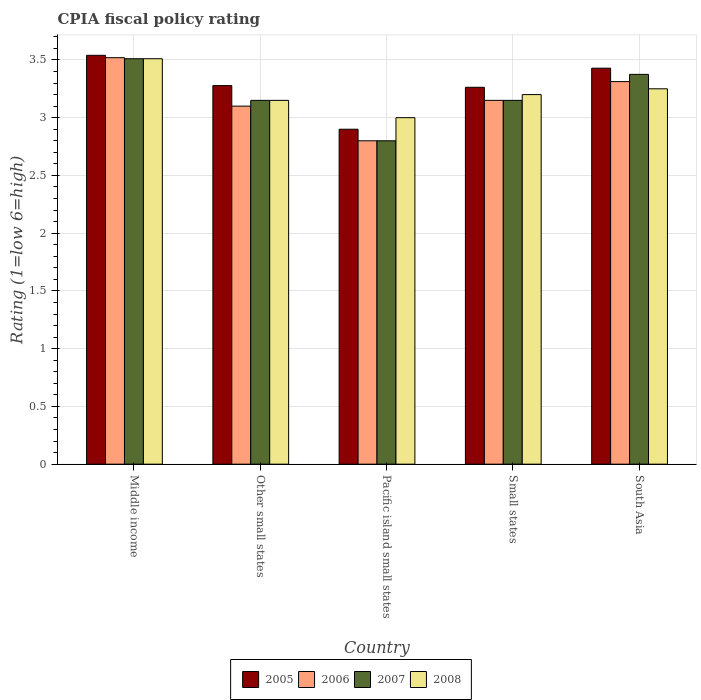How many different coloured bars are there?
Keep it short and to the point. 4. Are the number of bars per tick equal to the number of legend labels?
Keep it short and to the point. Yes. How many bars are there on the 4th tick from the right?
Give a very brief answer. 4. What is the label of the 4th group of bars from the left?
Your response must be concise. Small states. In how many cases, is the number of bars for a given country not equal to the number of legend labels?
Your answer should be compact. 0. What is the CPIA rating in 2005 in South Asia?
Keep it short and to the point. 3.43. Across all countries, what is the maximum CPIA rating in 2005?
Keep it short and to the point. 3.54. In which country was the CPIA rating in 2006 maximum?
Give a very brief answer. Middle income. In which country was the CPIA rating in 2007 minimum?
Offer a very short reply. Pacific island small states. What is the total CPIA rating in 2007 in the graph?
Your answer should be compact. 15.99. What is the difference between the CPIA rating in 2006 in Middle income and that in Other small states?
Your answer should be compact. 0.42. What is the difference between the CPIA rating in 2007 in South Asia and the CPIA rating in 2005 in Small states?
Make the answer very short. 0.11. What is the average CPIA rating in 2006 per country?
Give a very brief answer. 3.18. What is the difference between the CPIA rating of/in 2007 and CPIA rating of/in 2008 in Pacific island small states?
Keep it short and to the point. -0.2. In how many countries, is the CPIA rating in 2008 greater than 1.3?
Provide a short and direct response. 5. What is the ratio of the CPIA rating in 2008 in Other small states to that in Pacific island small states?
Give a very brief answer. 1.05. Is the CPIA rating in 2006 in Other small states less than that in Small states?
Ensure brevity in your answer.  Yes. What is the difference between the highest and the second highest CPIA rating in 2005?
Provide a succinct answer. -0.11. What is the difference between the highest and the lowest CPIA rating in 2007?
Your answer should be very brief. 0.71. Is it the case that in every country, the sum of the CPIA rating in 2006 and CPIA rating in 2005 is greater than the sum of CPIA rating in 2007 and CPIA rating in 2008?
Keep it short and to the point. No. What does the 3rd bar from the left in Pacific island small states represents?
Keep it short and to the point. 2007. What does the 3rd bar from the right in South Asia represents?
Provide a succinct answer. 2006. Is it the case that in every country, the sum of the CPIA rating in 2006 and CPIA rating in 2008 is greater than the CPIA rating in 2005?
Keep it short and to the point. Yes. Are all the bars in the graph horizontal?
Your answer should be very brief. No. How many countries are there in the graph?
Keep it short and to the point. 5. Does the graph contain any zero values?
Make the answer very short. No. Does the graph contain grids?
Provide a succinct answer. Yes. How many legend labels are there?
Offer a very short reply. 4. How are the legend labels stacked?
Provide a short and direct response. Horizontal. What is the title of the graph?
Provide a succinct answer. CPIA fiscal policy rating. What is the label or title of the Y-axis?
Offer a terse response. Rating (1=low 6=high). What is the Rating (1=low 6=high) of 2005 in Middle income?
Offer a very short reply. 3.54. What is the Rating (1=low 6=high) in 2006 in Middle income?
Keep it short and to the point. 3.52. What is the Rating (1=low 6=high) in 2007 in Middle income?
Give a very brief answer. 3.51. What is the Rating (1=low 6=high) in 2008 in Middle income?
Your answer should be compact. 3.51. What is the Rating (1=low 6=high) in 2005 in Other small states?
Your answer should be very brief. 3.28. What is the Rating (1=low 6=high) in 2006 in Other small states?
Offer a terse response. 3.1. What is the Rating (1=low 6=high) in 2007 in Other small states?
Provide a short and direct response. 3.15. What is the Rating (1=low 6=high) in 2008 in Other small states?
Your response must be concise. 3.15. What is the Rating (1=low 6=high) in 2006 in Pacific island small states?
Give a very brief answer. 2.8. What is the Rating (1=low 6=high) of 2008 in Pacific island small states?
Provide a short and direct response. 3. What is the Rating (1=low 6=high) of 2005 in Small states?
Give a very brief answer. 3.26. What is the Rating (1=low 6=high) of 2006 in Small states?
Your answer should be very brief. 3.15. What is the Rating (1=low 6=high) of 2007 in Small states?
Offer a very short reply. 3.15. What is the Rating (1=low 6=high) of 2008 in Small states?
Offer a very short reply. 3.2. What is the Rating (1=low 6=high) in 2005 in South Asia?
Provide a short and direct response. 3.43. What is the Rating (1=low 6=high) of 2006 in South Asia?
Provide a succinct answer. 3.31. What is the Rating (1=low 6=high) in 2007 in South Asia?
Offer a terse response. 3.38. Across all countries, what is the maximum Rating (1=low 6=high) of 2005?
Your answer should be very brief. 3.54. Across all countries, what is the maximum Rating (1=low 6=high) in 2006?
Provide a short and direct response. 3.52. Across all countries, what is the maximum Rating (1=low 6=high) in 2007?
Your answer should be very brief. 3.51. Across all countries, what is the maximum Rating (1=low 6=high) of 2008?
Your answer should be compact. 3.51. Across all countries, what is the minimum Rating (1=low 6=high) of 2006?
Your response must be concise. 2.8. Across all countries, what is the minimum Rating (1=low 6=high) in 2008?
Your answer should be compact. 3. What is the total Rating (1=low 6=high) in 2005 in the graph?
Your answer should be compact. 16.41. What is the total Rating (1=low 6=high) of 2006 in the graph?
Provide a short and direct response. 15.88. What is the total Rating (1=low 6=high) in 2007 in the graph?
Make the answer very short. 15.99. What is the total Rating (1=low 6=high) in 2008 in the graph?
Give a very brief answer. 16.11. What is the difference between the Rating (1=low 6=high) in 2005 in Middle income and that in Other small states?
Keep it short and to the point. 0.26. What is the difference between the Rating (1=low 6=high) in 2006 in Middle income and that in Other small states?
Offer a terse response. 0.42. What is the difference between the Rating (1=low 6=high) of 2007 in Middle income and that in Other small states?
Your answer should be compact. 0.36. What is the difference between the Rating (1=low 6=high) in 2008 in Middle income and that in Other small states?
Provide a short and direct response. 0.36. What is the difference between the Rating (1=low 6=high) in 2005 in Middle income and that in Pacific island small states?
Provide a succinct answer. 0.64. What is the difference between the Rating (1=low 6=high) in 2006 in Middle income and that in Pacific island small states?
Your answer should be compact. 0.72. What is the difference between the Rating (1=low 6=high) in 2007 in Middle income and that in Pacific island small states?
Give a very brief answer. 0.71. What is the difference between the Rating (1=low 6=high) in 2008 in Middle income and that in Pacific island small states?
Give a very brief answer. 0.51. What is the difference between the Rating (1=low 6=high) in 2005 in Middle income and that in Small states?
Offer a very short reply. 0.28. What is the difference between the Rating (1=low 6=high) of 2006 in Middle income and that in Small states?
Your response must be concise. 0.37. What is the difference between the Rating (1=low 6=high) in 2007 in Middle income and that in Small states?
Provide a short and direct response. 0.36. What is the difference between the Rating (1=low 6=high) in 2008 in Middle income and that in Small states?
Keep it short and to the point. 0.31. What is the difference between the Rating (1=low 6=high) of 2005 in Middle income and that in South Asia?
Provide a short and direct response. 0.11. What is the difference between the Rating (1=low 6=high) in 2006 in Middle income and that in South Asia?
Keep it short and to the point. 0.21. What is the difference between the Rating (1=low 6=high) in 2007 in Middle income and that in South Asia?
Your answer should be very brief. 0.14. What is the difference between the Rating (1=low 6=high) of 2008 in Middle income and that in South Asia?
Ensure brevity in your answer.  0.26. What is the difference between the Rating (1=low 6=high) of 2005 in Other small states and that in Pacific island small states?
Your answer should be very brief. 0.38. What is the difference between the Rating (1=low 6=high) in 2007 in Other small states and that in Pacific island small states?
Make the answer very short. 0.35. What is the difference between the Rating (1=low 6=high) in 2008 in Other small states and that in Pacific island small states?
Make the answer very short. 0.15. What is the difference between the Rating (1=low 6=high) of 2005 in Other small states and that in Small states?
Offer a terse response. 0.01. What is the difference between the Rating (1=low 6=high) in 2005 in Other small states and that in South Asia?
Keep it short and to the point. -0.15. What is the difference between the Rating (1=low 6=high) of 2006 in Other small states and that in South Asia?
Ensure brevity in your answer.  -0.21. What is the difference between the Rating (1=low 6=high) in 2007 in Other small states and that in South Asia?
Your answer should be compact. -0.23. What is the difference between the Rating (1=low 6=high) of 2008 in Other small states and that in South Asia?
Your response must be concise. -0.1. What is the difference between the Rating (1=low 6=high) of 2005 in Pacific island small states and that in Small states?
Ensure brevity in your answer.  -0.36. What is the difference between the Rating (1=low 6=high) of 2006 in Pacific island small states and that in Small states?
Your response must be concise. -0.35. What is the difference between the Rating (1=low 6=high) of 2007 in Pacific island small states and that in Small states?
Keep it short and to the point. -0.35. What is the difference between the Rating (1=low 6=high) of 2005 in Pacific island small states and that in South Asia?
Ensure brevity in your answer.  -0.53. What is the difference between the Rating (1=low 6=high) in 2006 in Pacific island small states and that in South Asia?
Your response must be concise. -0.51. What is the difference between the Rating (1=low 6=high) of 2007 in Pacific island small states and that in South Asia?
Offer a very short reply. -0.57. What is the difference between the Rating (1=low 6=high) of 2005 in Small states and that in South Asia?
Provide a succinct answer. -0.17. What is the difference between the Rating (1=low 6=high) in 2006 in Small states and that in South Asia?
Your answer should be very brief. -0.16. What is the difference between the Rating (1=low 6=high) in 2007 in Small states and that in South Asia?
Your answer should be very brief. -0.23. What is the difference between the Rating (1=low 6=high) of 2005 in Middle income and the Rating (1=low 6=high) of 2006 in Other small states?
Keep it short and to the point. 0.44. What is the difference between the Rating (1=low 6=high) in 2005 in Middle income and the Rating (1=low 6=high) in 2007 in Other small states?
Provide a succinct answer. 0.39. What is the difference between the Rating (1=low 6=high) in 2005 in Middle income and the Rating (1=low 6=high) in 2008 in Other small states?
Make the answer very short. 0.39. What is the difference between the Rating (1=low 6=high) of 2006 in Middle income and the Rating (1=low 6=high) of 2007 in Other small states?
Provide a short and direct response. 0.37. What is the difference between the Rating (1=low 6=high) in 2006 in Middle income and the Rating (1=low 6=high) in 2008 in Other small states?
Ensure brevity in your answer.  0.37. What is the difference between the Rating (1=low 6=high) of 2007 in Middle income and the Rating (1=low 6=high) of 2008 in Other small states?
Provide a succinct answer. 0.36. What is the difference between the Rating (1=low 6=high) of 2005 in Middle income and the Rating (1=low 6=high) of 2006 in Pacific island small states?
Offer a terse response. 0.74. What is the difference between the Rating (1=low 6=high) of 2005 in Middle income and the Rating (1=low 6=high) of 2007 in Pacific island small states?
Ensure brevity in your answer.  0.74. What is the difference between the Rating (1=low 6=high) in 2005 in Middle income and the Rating (1=low 6=high) in 2008 in Pacific island small states?
Your response must be concise. 0.54. What is the difference between the Rating (1=low 6=high) of 2006 in Middle income and the Rating (1=low 6=high) of 2007 in Pacific island small states?
Give a very brief answer. 0.72. What is the difference between the Rating (1=low 6=high) of 2006 in Middle income and the Rating (1=low 6=high) of 2008 in Pacific island small states?
Make the answer very short. 0.52. What is the difference between the Rating (1=low 6=high) in 2007 in Middle income and the Rating (1=low 6=high) in 2008 in Pacific island small states?
Offer a terse response. 0.51. What is the difference between the Rating (1=low 6=high) in 2005 in Middle income and the Rating (1=low 6=high) in 2006 in Small states?
Provide a short and direct response. 0.39. What is the difference between the Rating (1=low 6=high) in 2005 in Middle income and the Rating (1=low 6=high) in 2007 in Small states?
Your response must be concise. 0.39. What is the difference between the Rating (1=low 6=high) in 2005 in Middle income and the Rating (1=low 6=high) in 2008 in Small states?
Ensure brevity in your answer.  0.34. What is the difference between the Rating (1=low 6=high) in 2006 in Middle income and the Rating (1=low 6=high) in 2007 in Small states?
Your answer should be compact. 0.37. What is the difference between the Rating (1=low 6=high) in 2006 in Middle income and the Rating (1=low 6=high) in 2008 in Small states?
Provide a short and direct response. 0.32. What is the difference between the Rating (1=low 6=high) in 2007 in Middle income and the Rating (1=low 6=high) in 2008 in Small states?
Make the answer very short. 0.31. What is the difference between the Rating (1=low 6=high) of 2005 in Middle income and the Rating (1=low 6=high) of 2006 in South Asia?
Offer a very short reply. 0.23. What is the difference between the Rating (1=low 6=high) in 2005 in Middle income and the Rating (1=low 6=high) in 2007 in South Asia?
Your answer should be very brief. 0.17. What is the difference between the Rating (1=low 6=high) of 2005 in Middle income and the Rating (1=low 6=high) of 2008 in South Asia?
Offer a terse response. 0.29. What is the difference between the Rating (1=low 6=high) of 2006 in Middle income and the Rating (1=low 6=high) of 2007 in South Asia?
Offer a very short reply. 0.14. What is the difference between the Rating (1=low 6=high) of 2006 in Middle income and the Rating (1=low 6=high) of 2008 in South Asia?
Offer a terse response. 0.27. What is the difference between the Rating (1=low 6=high) in 2007 in Middle income and the Rating (1=low 6=high) in 2008 in South Asia?
Make the answer very short. 0.26. What is the difference between the Rating (1=low 6=high) of 2005 in Other small states and the Rating (1=low 6=high) of 2006 in Pacific island small states?
Make the answer very short. 0.48. What is the difference between the Rating (1=low 6=high) in 2005 in Other small states and the Rating (1=low 6=high) in 2007 in Pacific island small states?
Keep it short and to the point. 0.48. What is the difference between the Rating (1=low 6=high) in 2005 in Other small states and the Rating (1=low 6=high) in 2008 in Pacific island small states?
Your response must be concise. 0.28. What is the difference between the Rating (1=low 6=high) of 2006 in Other small states and the Rating (1=low 6=high) of 2008 in Pacific island small states?
Make the answer very short. 0.1. What is the difference between the Rating (1=low 6=high) of 2005 in Other small states and the Rating (1=low 6=high) of 2006 in Small states?
Offer a terse response. 0.13. What is the difference between the Rating (1=low 6=high) of 2005 in Other small states and the Rating (1=low 6=high) of 2007 in Small states?
Ensure brevity in your answer.  0.13. What is the difference between the Rating (1=low 6=high) of 2005 in Other small states and the Rating (1=low 6=high) of 2008 in Small states?
Offer a terse response. 0.08. What is the difference between the Rating (1=low 6=high) in 2005 in Other small states and the Rating (1=low 6=high) in 2006 in South Asia?
Give a very brief answer. -0.03. What is the difference between the Rating (1=low 6=high) of 2005 in Other small states and the Rating (1=low 6=high) of 2007 in South Asia?
Provide a short and direct response. -0.1. What is the difference between the Rating (1=low 6=high) in 2005 in Other small states and the Rating (1=low 6=high) in 2008 in South Asia?
Offer a very short reply. 0.03. What is the difference between the Rating (1=low 6=high) of 2006 in Other small states and the Rating (1=low 6=high) of 2007 in South Asia?
Keep it short and to the point. -0.28. What is the difference between the Rating (1=low 6=high) in 2006 in Other small states and the Rating (1=low 6=high) in 2008 in South Asia?
Provide a short and direct response. -0.15. What is the difference between the Rating (1=low 6=high) in 2006 in Pacific island small states and the Rating (1=low 6=high) in 2007 in Small states?
Your answer should be compact. -0.35. What is the difference between the Rating (1=low 6=high) in 2007 in Pacific island small states and the Rating (1=low 6=high) in 2008 in Small states?
Provide a short and direct response. -0.4. What is the difference between the Rating (1=low 6=high) in 2005 in Pacific island small states and the Rating (1=low 6=high) in 2006 in South Asia?
Your answer should be compact. -0.41. What is the difference between the Rating (1=low 6=high) in 2005 in Pacific island small states and the Rating (1=low 6=high) in 2007 in South Asia?
Offer a very short reply. -0.47. What is the difference between the Rating (1=low 6=high) of 2005 in Pacific island small states and the Rating (1=low 6=high) of 2008 in South Asia?
Provide a succinct answer. -0.35. What is the difference between the Rating (1=low 6=high) in 2006 in Pacific island small states and the Rating (1=low 6=high) in 2007 in South Asia?
Offer a very short reply. -0.57. What is the difference between the Rating (1=low 6=high) of 2006 in Pacific island small states and the Rating (1=low 6=high) of 2008 in South Asia?
Ensure brevity in your answer.  -0.45. What is the difference between the Rating (1=low 6=high) in 2007 in Pacific island small states and the Rating (1=low 6=high) in 2008 in South Asia?
Provide a short and direct response. -0.45. What is the difference between the Rating (1=low 6=high) in 2005 in Small states and the Rating (1=low 6=high) in 2006 in South Asia?
Offer a very short reply. -0.05. What is the difference between the Rating (1=low 6=high) in 2005 in Small states and the Rating (1=low 6=high) in 2007 in South Asia?
Make the answer very short. -0.11. What is the difference between the Rating (1=low 6=high) in 2005 in Small states and the Rating (1=low 6=high) in 2008 in South Asia?
Provide a short and direct response. 0.01. What is the difference between the Rating (1=low 6=high) of 2006 in Small states and the Rating (1=low 6=high) of 2007 in South Asia?
Provide a short and direct response. -0.23. What is the difference between the Rating (1=low 6=high) of 2007 in Small states and the Rating (1=low 6=high) of 2008 in South Asia?
Make the answer very short. -0.1. What is the average Rating (1=low 6=high) of 2005 per country?
Provide a succinct answer. 3.28. What is the average Rating (1=low 6=high) of 2006 per country?
Provide a succinct answer. 3.18. What is the average Rating (1=low 6=high) of 2007 per country?
Your answer should be compact. 3.2. What is the average Rating (1=low 6=high) of 2008 per country?
Provide a short and direct response. 3.22. What is the difference between the Rating (1=low 6=high) in 2005 and Rating (1=low 6=high) in 2006 in Middle income?
Your answer should be compact. 0.02. What is the difference between the Rating (1=low 6=high) of 2005 and Rating (1=low 6=high) of 2007 in Middle income?
Your response must be concise. 0.03. What is the difference between the Rating (1=low 6=high) in 2005 and Rating (1=low 6=high) in 2008 in Middle income?
Keep it short and to the point. 0.03. What is the difference between the Rating (1=low 6=high) of 2006 and Rating (1=low 6=high) of 2007 in Middle income?
Offer a terse response. 0.01. What is the difference between the Rating (1=low 6=high) in 2006 and Rating (1=low 6=high) in 2008 in Middle income?
Keep it short and to the point. 0.01. What is the difference between the Rating (1=low 6=high) in 2007 and Rating (1=low 6=high) in 2008 in Middle income?
Provide a short and direct response. 0. What is the difference between the Rating (1=low 6=high) of 2005 and Rating (1=low 6=high) of 2006 in Other small states?
Your answer should be very brief. 0.18. What is the difference between the Rating (1=low 6=high) of 2005 and Rating (1=low 6=high) of 2007 in Other small states?
Provide a succinct answer. 0.13. What is the difference between the Rating (1=low 6=high) of 2005 and Rating (1=low 6=high) of 2008 in Other small states?
Your answer should be compact. 0.13. What is the difference between the Rating (1=low 6=high) of 2007 and Rating (1=low 6=high) of 2008 in Other small states?
Your answer should be very brief. 0. What is the difference between the Rating (1=low 6=high) of 2005 and Rating (1=low 6=high) of 2007 in Pacific island small states?
Offer a very short reply. 0.1. What is the difference between the Rating (1=low 6=high) in 2005 and Rating (1=low 6=high) in 2008 in Pacific island small states?
Your response must be concise. -0.1. What is the difference between the Rating (1=low 6=high) of 2006 and Rating (1=low 6=high) of 2007 in Pacific island small states?
Your response must be concise. 0. What is the difference between the Rating (1=low 6=high) of 2006 and Rating (1=low 6=high) of 2008 in Pacific island small states?
Your answer should be very brief. -0.2. What is the difference between the Rating (1=low 6=high) of 2005 and Rating (1=low 6=high) of 2006 in Small states?
Your answer should be very brief. 0.11. What is the difference between the Rating (1=low 6=high) in 2005 and Rating (1=low 6=high) in 2007 in Small states?
Your response must be concise. 0.11. What is the difference between the Rating (1=low 6=high) in 2005 and Rating (1=low 6=high) in 2008 in Small states?
Provide a succinct answer. 0.06. What is the difference between the Rating (1=low 6=high) in 2006 and Rating (1=low 6=high) in 2008 in Small states?
Offer a very short reply. -0.05. What is the difference between the Rating (1=low 6=high) in 2007 and Rating (1=low 6=high) in 2008 in Small states?
Your answer should be compact. -0.05. What is the difference between the Rating (1=low 6=high) of 2005 and Rating (1=low 6=high) of 2006 in South Asia?
Offer a very short reply. 0.12. What is the difference between the Rating (1=low 6=high) of 2005 and Rating (1=low 6=high) of 2007 in South Asia?
Give a very brief answer. 0.05. What is the difference between the Rating (1=low 6=high) in 2005 and Rating (1=low 6=high) in 2008 in South Asia?
Give a very brief answer. 0.18. What is the difference between the Rating (1=low 6=high) in 2006 and Rating (1=low 6=high) in 2007 in South Asia?
Provide a succinct answer. -0.06. What is the difference between the Rating (1=low 6=high) in 2006 and Rating (1=low 6=high) in 2008 in South Asia?
Your answer should be compact. 0.06. What is the difference between the Rating (1=low 6=high) of 2007 and Rating (1=low 6=high) of 2008 in South Asia?
Your answer should be compact. 0.12. What is the ratio of the Rating (1=low 6=high) of 2006 in Middle income to that in Other small states?
Provide a succinct answer. 1.14. What is the ratio of the Rating (1=low 6=high) of 2007 in Middle income to that in Other small states?
Keep it short and to the point. 1.11. What is the ratio of the Rating (1=low 6=high) in 2008 in Middle income to that in Other small states?
Offer a terse response. 1.11. What is the ratio of the Rating (1=low 6=high) in 2005 in Middle income to that in Pacific island small states?
Make the answer very short. 1.22. What is the ratio of the Rating (1=low 6=high) of 2006 in Middle income to that in Pacific island small states?
Make the answer very short. 1.26. What is the ratio of the Rating (1=low 6=high) in 2007 in Middle income to that in Pacific island small states?
Give a very brief answer. 1.25. What is the ratio of the Rating (1=low 6=high) in 2008 in Middle income to that in Pacific island small states?
Offer a very short reply. 1.17. What is the ratio of the Rating (1=low 6=high) of 2005 in Middle income to that in Small states?
Your answer should be very brief. 1.08. What is the ratio of the Rating (1=low 6=high) of 2006 in Middle income to that in Small states?
Ensure brevity in your answer.  1.12. What is the ratio of the Rating (1=low 6=high) of 2007 in Middle income to that in Small states?
Provide a short and direct response. 1.11. What is the ratio of the Rating (1=low 6=high) of 2008 in Middle income to that in Small states?
Your response must be concise. 1.1. What is the ratio of the Rating (1=low 6=high) of 2005 in Middle income to that in South Asia?
Keep it short and to the point. 1.03. What is the ratio of the Rating (1=low 6=high) in 2006 in Middle income to that in South Asia?
Your answer should be very brief. 1.06. What is the ratio of the Rating (1=low 6=high) in 2007 in Middle income to that in South Asia?
Your response must be concise. 1.04. What is the ratio of the Rating (1=low 6=high) in 2008 in Middle income to that in South Asia?
Provide a succinct answer. 1.08. What is the ratio of the Rating (1=low 6=high) of 2005 in Other small states to that in Pacific island small states?
Provide a succinct answer. 1.13. What is the ratio of the Rating (1=low 6=high) in 2006 in Other small states to that in Pacific island small states?
Provide a short and direct response. 1.11. What is the ratio of the Rating (1=low 6=high) in 2007 in Other small states to that in Pacific island small states?
Give a very brief answer. 1.12. What is the ratio of the Rating (1=low 6=high) in 2008 in Other small states to that in Pacific island small states?
Provide a succinct answer. 1.05. What is the ratio of the Rating (1=low 6=high) in 2006 in Other small states to that in Small states?
Your answer should be very brief. 0.98. What is the ratio of the Rating (1=low 6=high) in 2008 in Other small states to that in Small states?
Give a very brief answer. 0.98. What is the ratio of the Rating (1=low 6=high) in 2005 in Other small states to that in South Asia?
Offer a terse response. 0.96. What is the ratio of the Rating (1=low 6=high) of 2006 in Other small states to that in South Asia?
Your answer should be very brief. 0.94. What is the ratio of the Rating (1=low 6=high) in 2008 in Other small states to that in South Asia?
Your answer should be compact. 0.97. What is the ratio of the Rating (1=low 6=high) in 2005 in Pacific island small states to that in Small states?
Offer a terse response. 0.89. What is the ratio of the Rating (1=low 6=high) in 2008 in Pacific island small states to that in Small states?
Give a very brief answer. 0.94. What is the ratio of the Rating (1=low 6=high) of 2005 in Pacific island small states to that in South Asia?
Offer a terse response. 0.85. What is the ratio of the Rating (1=low 6=high) in 2006 in Pacific island small states to that in South Asia?
Make the answer very short. 0.85. What is the ratio of the Rating (1=low 6=high) of 2007 in Pacific island small states to that in South Asia?
Make the answer very short. 0.83. What is the ratio of the Rating (1=low 6=high) of 2008 in Pacific island small states to that in South Asia?
Make the answer very short. 0.92. What is the ratio of the Rating (1=low 6=high) in 2005 in Small states to that in South Asia?
Provide a short and direct response. 0.95. What is the ratio of the Rating (1=low 6=high) of 2006 in Small states to that in South Asia?
Ensure brevity in your answer.  0.95. What is the ratio of the Rating (1=low 6=high) in 2007 in Small states to that in South Asia?
Offer a very short reply. 0.93. What is the ratio of the Rating (1=low 6=high) of 2008 in Small states to that in South Asia?
Make the answer very short. 0.98. What is the difference between the highest and the second highest Rating (1=low 6=high) in 2005?
Your answer should be compact. 0.11. What is the difference between the highest and the second highest Rating (1=low 6=high) in 2006?
Keep it short and to the point. 0.21. What is the difference between the highest and the second highest Rating (1=low 6=high) in 2007?
Provide a short and direct response. 0.14. What is the difference between the highest and the second highest Rating (1=low 6=high) in 2008?
Your answer should be very brief. 0.26. What is the difference between the highest and the lowest Rating (1=low 6=high) of 2005?
Provide a short and direct response. 0.64. What is the difference between the highest and the lowest Rating (1=low 6=high) in 2006?
Offer a very short reply. 0.72. What is the difference between the highest and the lowest Rating (1=low 6=high) in 2007?
Offer a terse response. 0.71. What is the difference between the highest and the lowest Rating (1=low 6=high) in 2008?
Give a very brief answer. 0.51. 